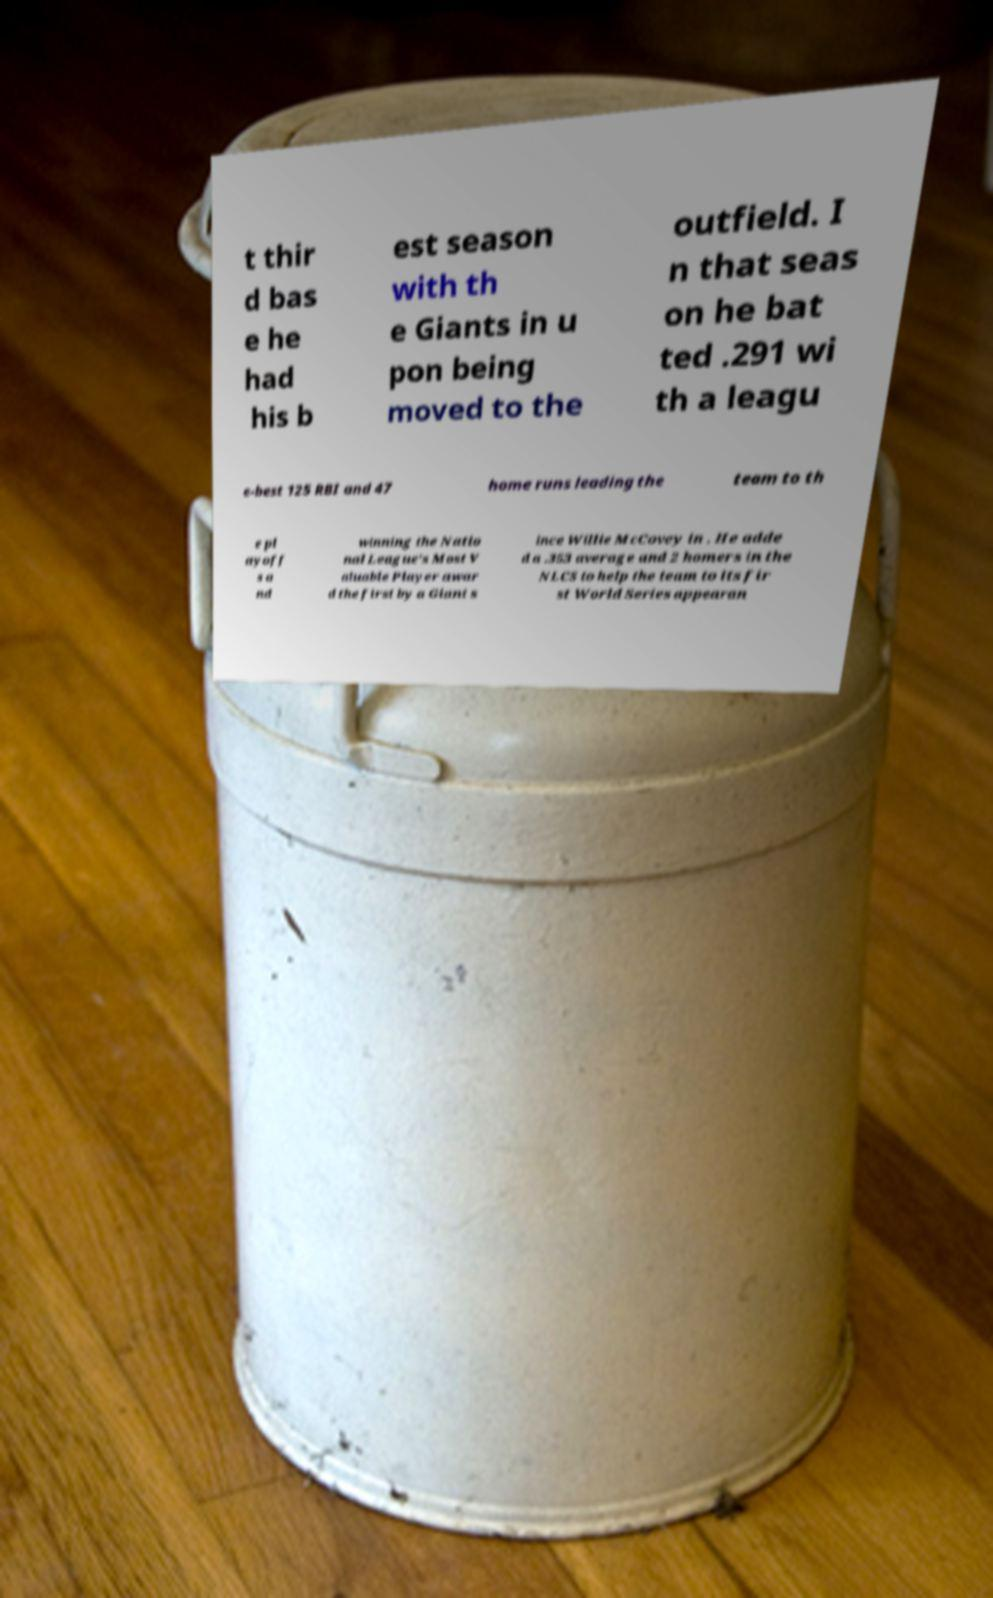What messages or text are displayed in this image? I need them in a readable, typed format. t thir d bas e he had his b est season with th e Giants in u pon being moved to the outfield. I n that seas on he bat ted .291 wi th a leagu e-best 125 RBI and 47 home runs leading the team to th e pl ayoff s a nd winning the Natio nal League's Most V aluable Player awar d the first by a Giant s ince Willie McCovey in . He adde d a .353 average and 2 homers in the NLCS to help the team to its fir st World Series appearan 